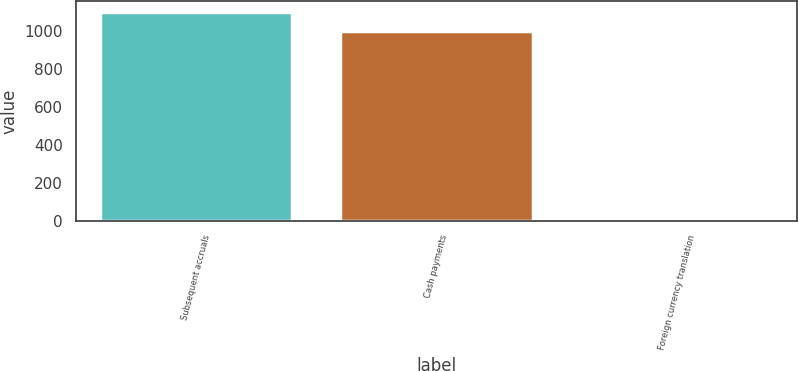<chart> <loc_0><loc_0><loc_500><loc_500><bar_chart><fcel>Subsequent accruals<fcel>Cash payments<fcel>Foreign currency translation<nl><fcel>1100<fcel>1000<fcel>1<nl></chart> 